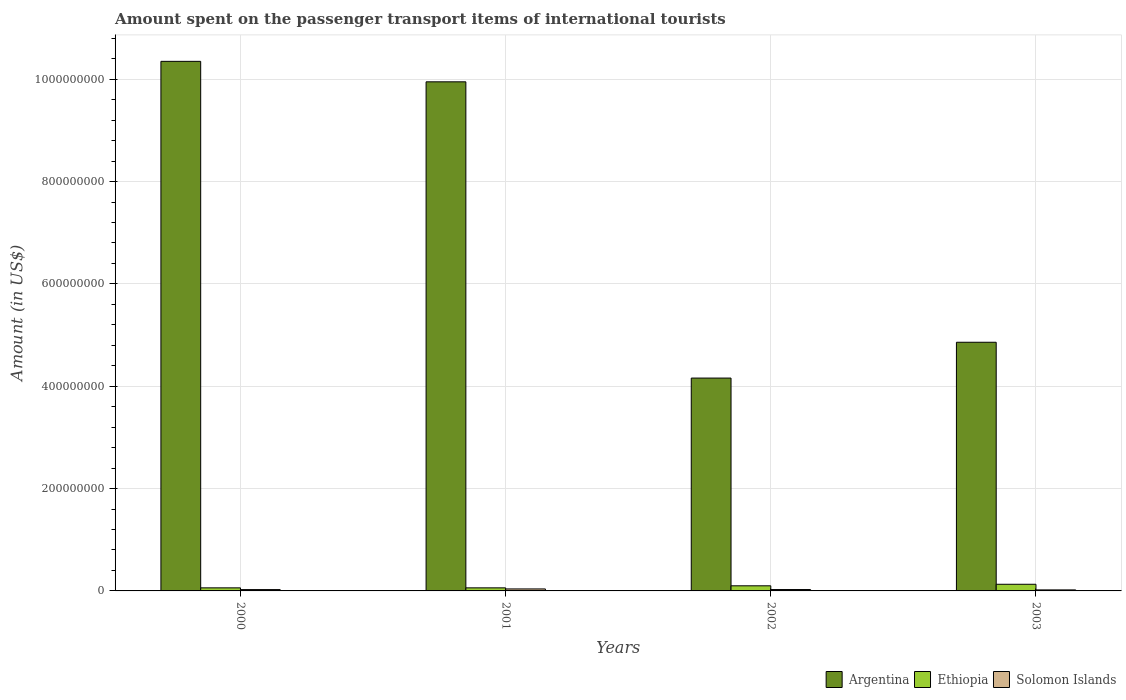How many different coloured bars are there?
Your response must be concise. 3. How many groups of bars are there?
Give a very brief answer. 4. Are the number of bars per tick equal to the number of legend labels?
Give a very brief answer. Yes. Are the number of bars on each tick of the X-axis equal?
Your answer should be compact. Yes. How many bars are there on the 4th tick from the right?
Your answer should be very brief. 3. In how many cases, is the number of bars for a given year not equal to the number of legend labels?
Your answer should be compact. 0. What is the amount spent on the passenger transport items of international tourists in Solomon Islands in 2000?
Your response must be concise. 2.60e+06. Across all years, what is the maximum amount spent on the passenger transport items of international tourists in Solomon Islands?
Provide a succinct answer. 3.90e+06. Across all years, what is the minimum amount spent on the passenger transport items of international tourists in Argentina?
Your answer should be very brief. 4.16e+08. In which year was the amount spent on the passenger transport items of international tourists in Solomon Islands maximum?
Your answer should be compact. 2001. In which year was the amount spent on the passenger transport items of international tourists in Ethiopia minimum?
Give a very brief answer. 2000. What is the total amount spent on the passenger transport items of international tourists in Solomon Islands in the graph?
Keep it short and to the point. 1.12e+07. What is the difference between the amount spent on the passenger transport items of international tourists in Solomon Islands in 2000 and that in 2003?
Ensure brevity in your answer.  6.00e+05. What is the difference between the amount spent on the passenger transport items of international tourists in Argentina in 2003 and the amount spent on the passenger transport items of international tourists in Solomon Islands in 2001?
Keep it short and to the point. 4.82e+08. What is the average amount spent on the passenger transport items of international tourists in Argentina per year?
Your answer should be very brief. 7.33e+08. In the year 2003, what is the difference between the amount spent on the passenger transport items of international tourists in Solomon Islands and amount spent on the passenger transport items of international tourists in Ethiopia?
Your answer should be very brief. -1.10e+07. Is the amount spent on the passenger transport items of international tourists in Solomon Islands in 2000 less than that in 2003?
Keep it short and to the point. No. What is the difference between the highest and the second highest amount spent on the passenger transport items of international tourists in Argentina?
Your answer should be compact. 4.00e+07. What is the difference between the highest and the lowest amount spent on the passenger transport items of international tourists in Solomon Islands?
Offer a terse response. 1.90e+06. Is the sum of the amount spent on the passenger transport items of international tourists in Argentina in 2001 and 2002 greater than the maximum amount spent on the passenger transport items of international tourists in Solomon Islands across all years?
Offer a terse response. Yes. What does the 3rd bar from the left in 2000 represents?
Offer a very short reply. Solomon Islands. What does the 1st bar from the right in 2003 represents?
Your response must be concise. Solomon Islands. Are all the bars in the graph horizontal?
Keep it short and to the point. No. What is the difference between two consecutive major ticks on the Y-axis?
Make the answer very short. 2.00e+08. Are the values on the major ticks of Y-axis written in scientific E-notation?
Your answer should be very brief. No. Does the graph contain grids?
Give a very brief answer. Yes. How many legend labels are there?
Offer a terse response. 3. How are the legend labels stacked?
Keep it short and to the point. Horizontal. What is the title of the graph?
Keep it short and to the point. Amount spent on the passenger transport items of international tourists. Does "Euro area" appear as one of the legend labels in the graph?
Keep it short and to the point. No. What is the label or title of the Y-axis?
Offer a very short reply. Amount (in US$). What is the Amount (in US$) in Argentina in 2000?
Keep it short and to the point. 1.04e+09. What is the Amount (in US$) of Ethiopia in 2000?
Your answer should be very brief. 6.00e+06. What is the Amount (in US$) in Solomon Islands in 2000?
Your response must be concise. 2.60e+06. What is the Amount (in US$) in Argentina in 2001?
Offer a terse response. 9.95e+08. What is the Amount (in US$) in Solomon Islands in 2001?
Offer a very short reply. 3.90e+06. What is the Amount (in US$) of Argentina in 2002?
Make the answer very short. 4.16e+08. What is the Amount (in US$) in Ethiopia in 2002?
Your response must be concise. 1.00e+07. What is the Amount (in US$) in Solomon Islands in 2002?
Offer a very short reply. 2.70e+06. What is the Amount (in US$) in Argentina in 2003?
Your response must be concise. 4.86e+08. What is the Amount (in US$) of Ethiopia in 2003?
Give a very brief answer. 1.30e+07. Across all years, what is the maximum Amount (in US$) in Argentina?
Offer a terse response. 1.04e+09. Across all years, what is the maximum Amount (in US$) of Ethiopia?
Your response must be concise. 1.30e+07. Across all years, what is the maximum Amount (in US$) of Solomon Islands?
Make the answer very short. 3.90e+06. Across all years, what is the minimum Amount (in US$) in Argentina?
Your answer should be compact. 4.16e+08. Across all years, what is the minimum Amount (in US$) of Ethiopia?
Provide a succinct answer. 6.00e+06. What is the total Amount (in US$) of Argentina in the graph?
Your response must be concise. 2.93e+09. What is the total Amount (in US$) of Ethiopia in the graph?
Offer a very short reply. 3.50e+07. What is the total Amount (in US$) of Solomon Islands in the graph?
Keep it short and to the point. 1.12e+07. What is the difference between the Amount (in US$) of Argentina in 2000 and that in 2001?
Make the answer very short. 4.00e+07. What is the difference between the Amount (in US$) of Ethiopia in 2000 and that in 2001?
Keep it short and to the point. 0. What is the difference between the Amount (in US$) in Solomon Islands in 2000 and that in 2001?
Provide a succinct answer. -1.30e+06. What is the difference between the Amount (in US$) in Argentina in 2000 and that in 2002?
Keep it short and to the point. 6.19e+08. What is the difference between the Amount (in US$) in Solomon Islands in 2000 and that in 2002?
Provide a short and direct response. -1.00e+05. What is the difference between the Amount (in US$) of Argentina in 2000 and that in 2003?
Provide a succinct answer. 5.49e+08. What is the difference between the Amount (in US$) of Ethiopia in 2000 and that in 2003?
Offer a terse response. -7.00e+06. What is the difference between the Amount (in US$) in Solomon Islands in 2000 and that in 2003?
Make the answer very short. 6.00e+05. What is the difference between the Amount (in US$) of Argentina in 2001 and that in 2002?
Keep it short and to the point. 5.79e+08. What is the difference between the Amount (in US$) in Solomon Islands in 2001 and that in 2002?
Make the answer very short. 1.20e+06. What is the difference between the Amount (in US$) of Argentina in 2001 and that in 2003?
Ensure brevity in your answer.  5.09e+08. What is the difference between the Amount (in US$) in Ethiopia in 2001 and that in 2003?
Provide a short and direct response. -7.00e+06. What is the difference between the Amount (in US$) in Solomon Islands in 2001 and that in 2003?
Offer a very short reply. 1.90e+06. What is the difference between the Amount (in US$) in Argentina in 2002 and that in 2003?
Keep it short and to the point. -7.00e+07. What is the difference between the Amount (in US$) in Ethiopia in 2002 and that in 2003?
Your answer should be very brief. -3.00e+06. What is the difference between the Amount (in US$) of Argentina in 2000 and the Amount (in US$) of Ethiopia in 2001?
Your answer should be compact. 1.03e+09. What is the difference between the Amount (in US$) in Argentina in 2000 and the Amount (in US$) in Solomon Islands in 2001?
Provide a short and direct response. 1.03e+09. What is the difference between the Amount (in US$) in Ethiopia in 2000 and the Amount (in US$) in Solomon Islands in 2001?
Provide a succinct answer. 2.10e+06. What is the difference between the Amount (in US$) in Argentina in 2000 and the Amount (in US$) in Ethiopia in 2002?
Your answer should be compact. 1.02e+09. What is the difference between the Amount (in US$) in Argentina in 2000 and the Amount (in US$) in Solomon Islands in 2002?
Your answer should be very brief. 1.03e+09. What is the difference between the Amount (in US$) of Ethiopia in 2000 and the Amount (in US$) of Solomon Islands in 2002?
Offer a very short reply. 3.30e+06. What is the difference between the Amount (in US$) in Argentina in 2000 and the Amount (in US$) in Ethiopia in 2003?
Offer a terse response. 1.02e+09. What is the difference between the Amount (in US$) of Argentina in 2000 and the Amount (in US$) of Solomon Islands in 2003?
Make the answer very short. 1.03e+09. What is the difference between the Amount (in US$) of Ethiopia in 2000 and the Amount (in US$) of Solomon Islands in 2003?
Make the answer very short. 4.00e+06. What is the difference between the Amount (in US$) in Argentina in 2001 and the Amount (in US$) in Ethiopia in 2002?
Provide a succinct answer. 9.85e+08. What is the difference between the Amount (in US$) of Argentina in 2001 and the Amount (in US$) of Solomon Islands in 2002?
Make the answer very short. 9.92e+08. What is the difference between the Amount (in US$) in Ethiopia in 2001 and the Amount (in US$) in Solomon Islands in 2002?
Your answer should be compact. 3.30e+06. What is the difference between the Amount (in US$) in Argentina in 2001 and the Amount (in US$) in Ethiopia in 2003?
Make the answer very short. 9.82e+08. What is the difference between the Amount (in US$) of Argentina in 2001 and the Amount (in US$) of Solomon Islands in 2003?
Make the answer very short. 9.93e+08. What is the difference between the Amount (in US$) of Argentina in 2002 and the Amount (in US$) of Ethiopia in 2003?
Keep it short and to the point. 4.03e+08. What is the difference between the Amount (in US$) of Argentina in 2002 and the Amount (in US$) of Solomon Islands in 2003?
Make the answer very short. 4.14e+08. What is the average Amount (in US$) of Argentina per year?
Provide a succinct answer. 7.33e+08. What is the average Amount (in US$) in Ethiopia per year?
Your response must be concise. 8.75e+06. What is the average Amount (in US$) in Solomon Islands per year?
Your answer should be compact. 2.80e+06. In the year 2000, what is the difference between the Amount (in US$) of Argentina and Amount (in US$) of Ethiopia?
Provide a succinct answer. 1.03e+09. In the year 2000, what is the difference between the Amount (in US$) of Argentina and Amount (in US$) of Solomon Islands?
Keep it short and to the point. 1.03e+09. In the year 2000, what is the difference between the Amount (in US$) of Ethiopia and Amount (in US$) of Solomon Islands?
Offer a terse response. 3.40e+06. In the year 2001, what is the difference between the Amount (in US$) in Argentina and Amount (in US$) in Ethiopia?
Your answer should be compact. 9.89e+08. In the year 2001, what is the difference between the Amount (in US$) in Argentina and Amount (in US$) in Solomon Islands?
Ensure brevity in your answer.  9.91e+08. In the year 2001, what is the difference between the Amount (in US$) of Ethiopia and Amount (in US$) of Solomon Islands?
Offer a very short reply. 2.10e+06. In the year 2002, what is the difference between the Amount (in US$) in Argentina and Amount (in US$) in Ethiopia?
Your response must be concise. 4.06e+08. In the year 2002, what is the difference between the Amount (in US$) of Argentina and Amount (in US$) of Solomon Islands?
Provide a succinct answer. 4.13e+08. In the year 2002, what is the difference between the Amount (in US$) of Ethiopia and Amount (in US$) of Solomon Islands?
Give a very brief answer. 7.30e+06. In the year 2003, what is the difference between the Amount (in US$) in Argentina and Amount (in US$) in Ethiopia?
Offer a terse response. 4.73e+08. In the year 2003, what is the difference between the Amount (in US$) of Argentina and Amount (in US$) of Solomon Islands?
Offer a very short reply. 4.84e+08. In the year 2003, what is the difference between the Amount (in US$) in Ethiopia and Amount (in US$) in Solomon Islands?
Your answer should be compact. 1.10e+07. What is the ratio of the Amount (in US$) in Argentina in 2000 to that in 2001?
Offer a very short reply. 1.04. What is the ratio of the Amount (in US$) in Ethiopia in 2000 to that in 2001?
Offer a very short reply. 1. What is the ratio of the Amount (in US$) of Solomon Islands in 2000 to that in 2001?
Ensure brevity in your answer.  0.67. What is the ratio of the Amount (in US$) of Argentina in 2000 to that in 2002?
Your response must be concise. 2.49. What is the ratio of the Amount (in US$) in Ethiopia in 2000 to that in 2002?
Give a very brief answer. 0.6. What is the ratio of the Amount (in US$) in Argentina in 2000 to that in 2003?
Your answer should be compact. 2.13. What is the ratio of the Amount (in US$) in Ethiopia in 2000 to that in 2003?
Provide a succinct answer. 0.46. What is the ratio of the Amount (in US$) of Argentina in 2001 to that in 2002?
Offer a terse response. 2.39. What is the ratio of the Amount (in US$) of Ethiopia in 2001 to that in 2002?
Keep it short and to the point. 0.6. What is the ratio of the Amount (in US$) in Solomon Islands in 2001 to that in 2002?
Give a very brief answer. 1.44. What is the ratio of the Amount (in US$) of Argentina in 2001 to that in 2003?
Provide a short and direct response. 2.05. What is the ratio of the Amount (in US$) in Ethiopia in 2001 to that in 2003?
Provide a succinct answer. 0.46. What is the ratio of the Amount (in US$) of Solomon Islands in 2001 to that in 2003?
Your answer should be compact. 1.95. What is the ratio of the Amount (in US$) in Argentina in 2002 to that in 2003?
Offer a very short reply. 0.86. What is the ratio of the Amount (in US$) in Ethiopia in 2002 to that in 2003?
Offer a terse response. 0.77. What is the ratio of the Amount (in US$) of Solomon Islands in 2002 to that in 2003?
Keep it short and to the point. 1.35. What is the difference between the highest and the second highest Amount (in US$) of Argentina?
Your answer should be very brief. 4.00e+07. What is the difference between the highest and the second highest Amount (in US$) in Solomon Islands?
Your answer should be very brief. 1.20e+06. What is the difference between the highest and the lowest Amount (in US$) in Argentina?
Offer a terse response. 6.19e+08. What is the difference between the highest and the lowest Amount (in US$) of Ethiopia?
Offer a very short reply. 7.00e+06. What is the difference between the highest and the lowest Amount (in US$) of Solomon Islands?
Provide a succinct answer. 1.90e+06. 